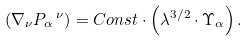<formula> <loc_0><loc_0><loc_500><loc_500>\left ( { \nabla _ { \nu } P _ { \alpha } \, ^ { \nu } } \right ) = C o n s t \cdot \left ( { \lambda ^ { 3 / 2 } \cdot \Upsilon _ { \alpha } } \right ) .</formula> 